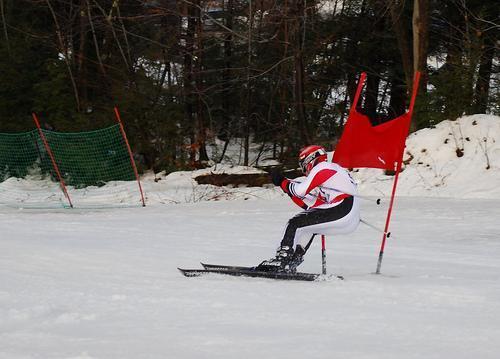How many yellow umbrellas are there?
Give a very brief answer. 0. 